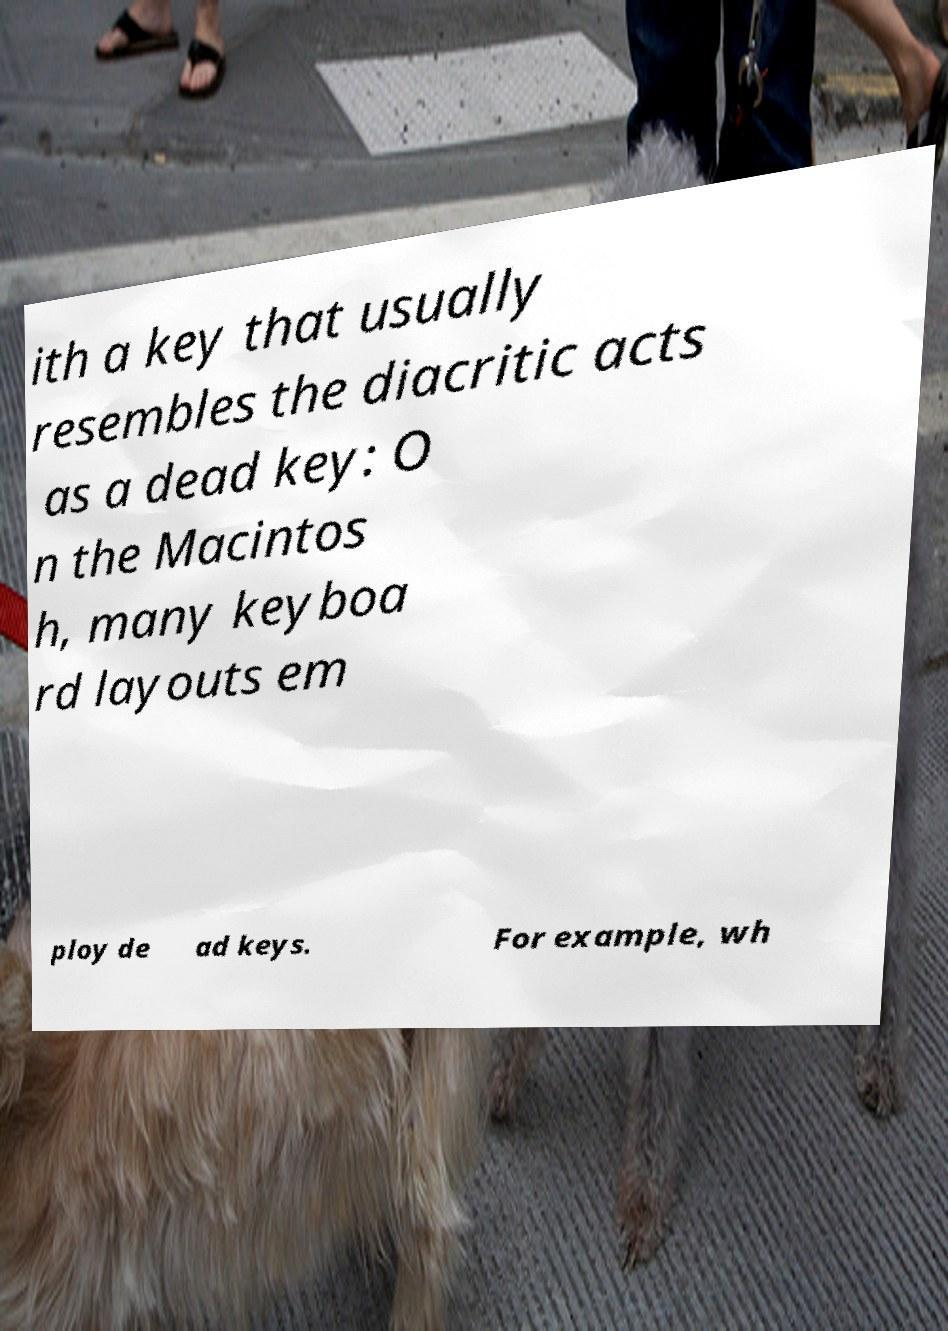What messages or text are displayed in this image? I need them in a readable, typed format. ith a key that usually resembles the diacritic acts as a dead key: O n the Macintos h, many keyboa rd layouts em ploy de ad keys. For example, wh 